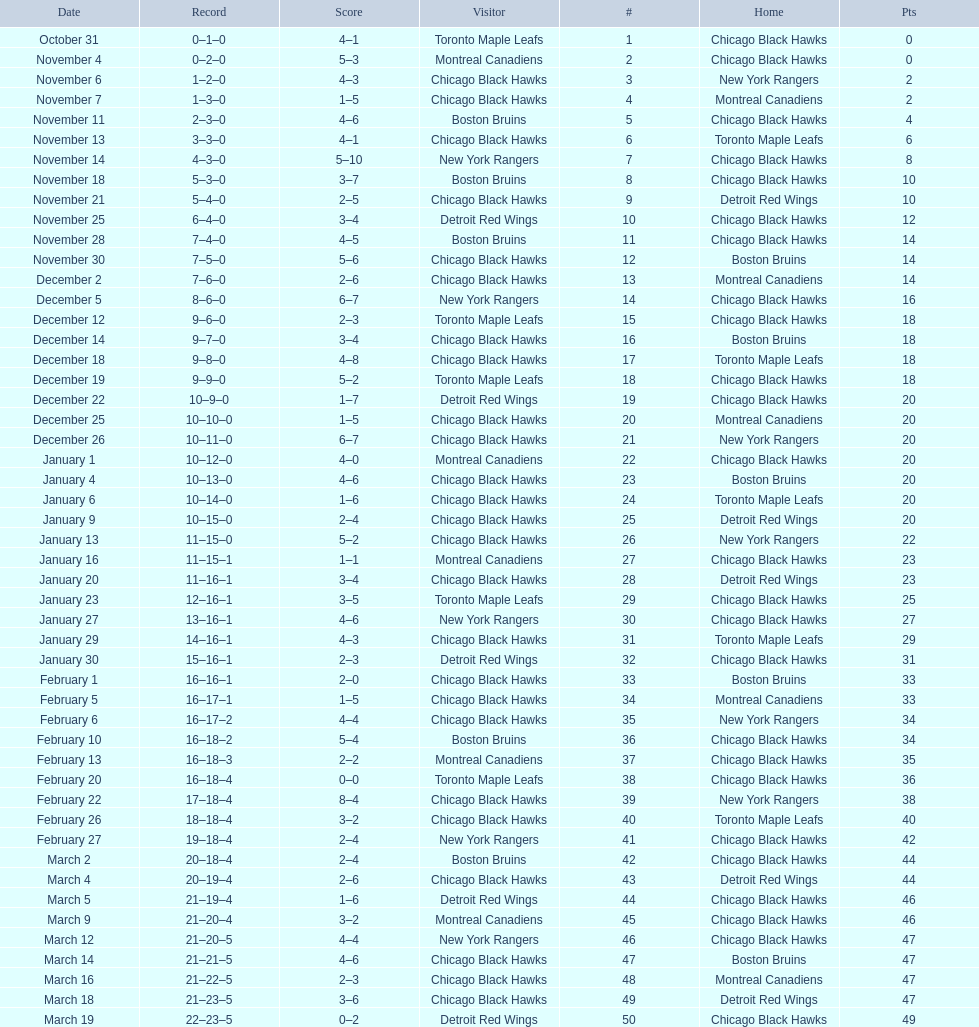How many total games did they win? 22. 